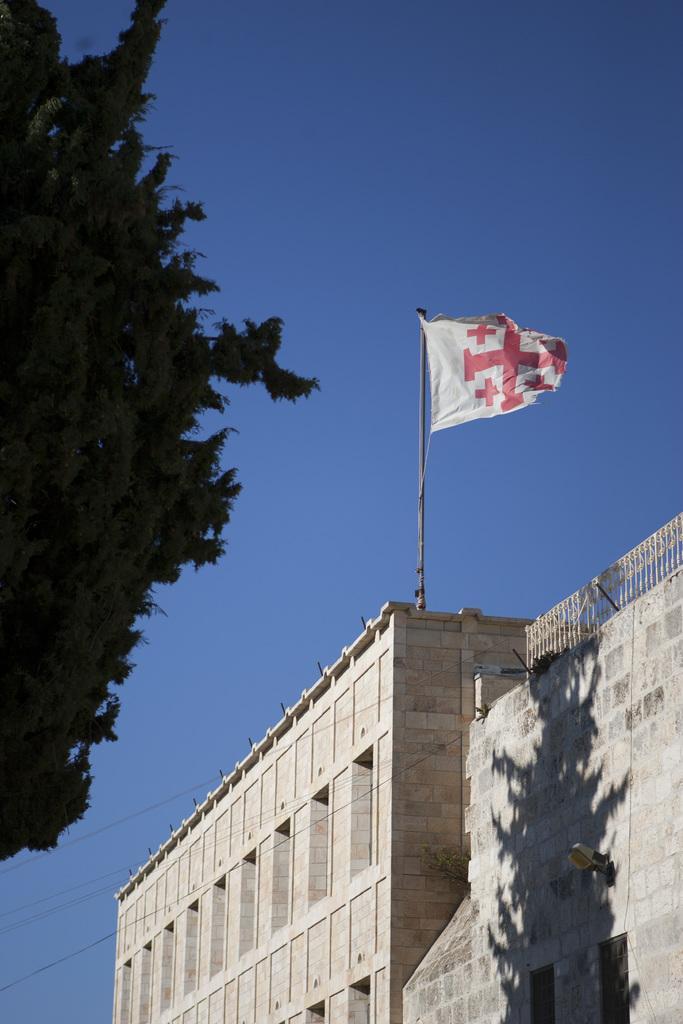Please provide a concise description of this image. An outdoor picture. Sky is in blue color. This is a tree. This is a building. Flag is on building. 